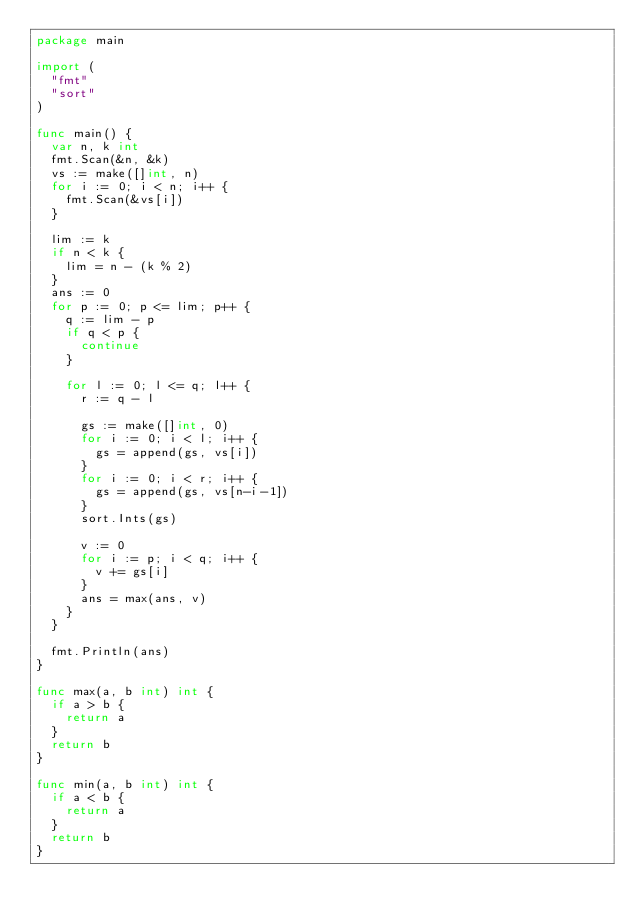Convert code to text. <code><loc_0><loc_0><loc_500><loc_500><_Go_>package main

import (
	"fmt"
	"sort"
)

func main() {
	var n, k int
	fmt.Scan(&n, &k)
	vs := make([]int, n)
	for i := 0; i < n; i++ {
		fmt.Scan(&vs[i])
	}

	lim := k
	if n < k {
		lim = n - (k % 2)
	}
	ans := 0
	for p := 0; p <= lim; p++ {
		q := lim - p
		if q < p {
			continue
		}

		for l := 0; l <= q; l++ {
			r := q - l

			gs := make([]int, 0)
			for i := 0; i < l; i++ {
				gs = append(gs, vs[i])
			}
			for i := 0; i < r; i++ {
				gs = append(gs, vs[n-i-1])
			}
			sort.Ints(gs)

			v := 0
			for i := p; i < q; i++ {
				v += gs[i]
			}
			ans = max(ans, v)
		}
	}

	fmt.Println(ans)
}

func max(a, b int) int {
	if a > b {
		return a
	}
	return b
}

func min(a, b int) int {
	if a < b {
		return a
	}
	return b
}
</code> 